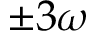<formula> <loc_0><loc_0><loc_500><loc_500>\pm 3 \omega</formula> 